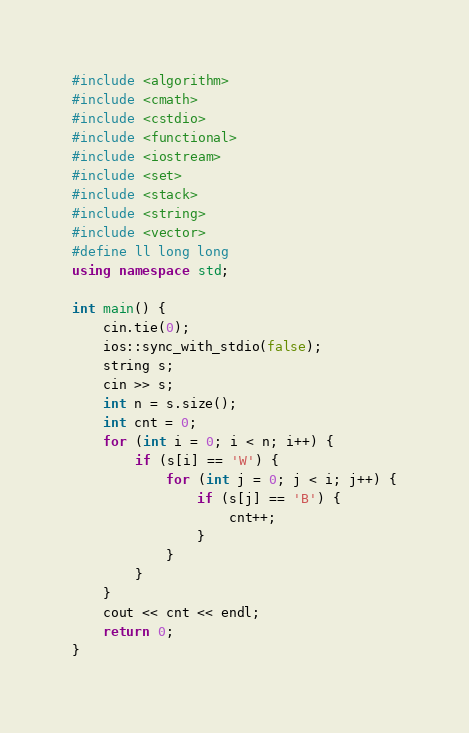Convert code to text. <code><loc_0><loc_0><loc_500><loc_500><_C++_>#include <algorithm>
#include <cmath>
#include <cstdio>
#include <functional>
#include <iostream>
#include <set>
#include <stack>
#include <string>
#include <vector>
#define ll long long
using namespace std;

int main() {
    cin.tie(0);
    ios::sync_with_stdio(false);
    string s;
    cin >> s;
    int n = s.size();
    int cnt = 0;
    for (int i = 0; i < n; i++) {
        if (s[i] == 'W') {
            for (int j = 0; j < i; j++) {
                if (s[j] == 'B') {
                    cnt++;
                }
            }
        }
    }
    cout << cnt << endl;
    return 0;
}</code> 